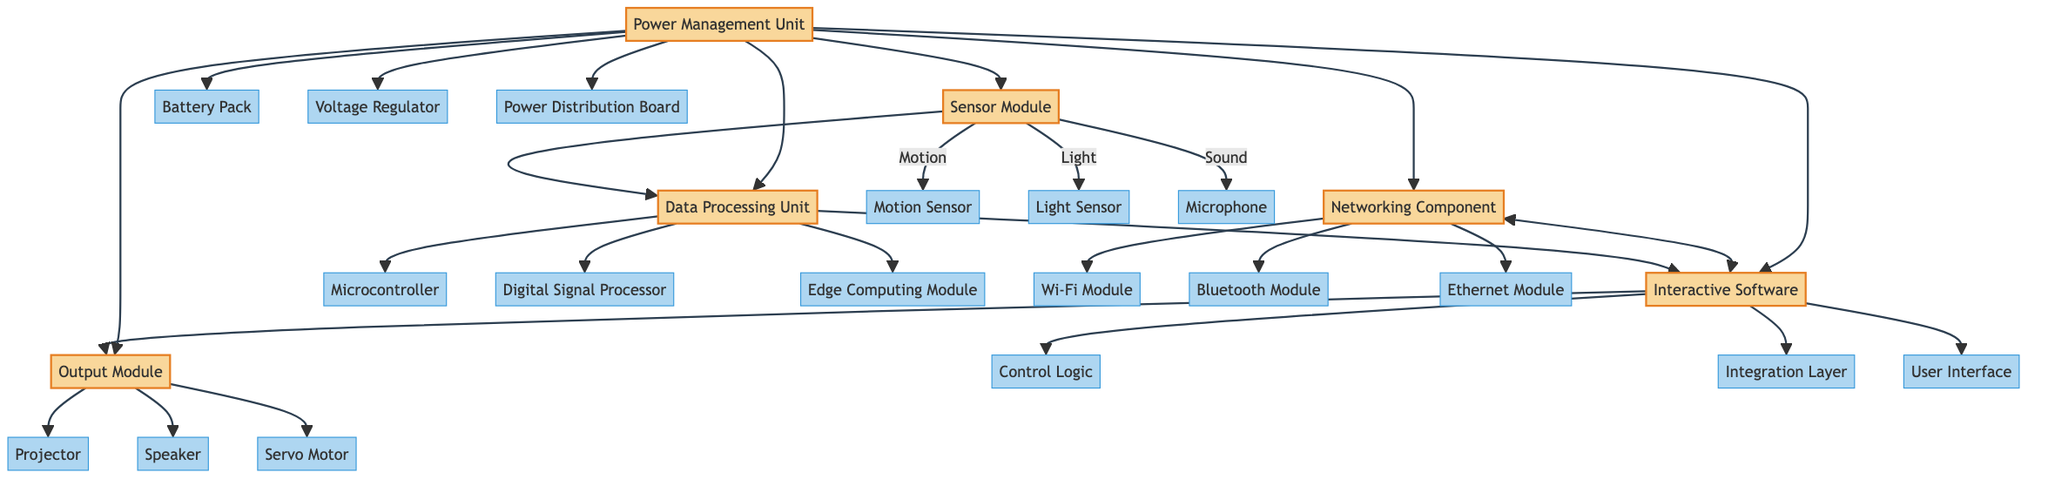What is the main purpose of the Sensor Module? The Sensor Module captures environmental inputs such as motion, light, and sound. This is indicated by its description provided in the diagram.
Answer: Captures environmental inputs How many software modules are present in the Interactive Software? The Interactive Software consists of three software modules: Control Logic, Integration Layer, and User Interface. Counting these components shows that there are three modules.
Answer: Three software modules Which module communicates bidirectionally with the Networking Component? The Interactive Software communicates bidirectionally with the Networking Component, as shown by the two-way arrow between these two modules in the diagram.
Answer: Interactive Software What types of inputs does the Sensor Module provide? The inputs from the Sensor Module include Motion, Light, and Sound, which are labeled on the connections from the Sensor Module to its components in the diagram.
Answer: Motion, Light, Sound How is power distributed to all components? The Power Management Unit distributes power to other components (Sensor Module, Data Processing Unit, Interactive Software, Output Module, Networking Component) as indicated by its connections in the diagram.
Answer: Power Management Unit Which output device is associated with audio feedback? The Speaker component in the Output Module is associated with audio feedback, as it is listed under the Outputs in the diagram.
Answer: Speaker In total, how many main modules are there in the entire block diagram? The entire block diagram consists of six main modules: Sensor Module, Data Processing Unit, Interactive Software, Output Module, Networking Component, and Power Management Unit. Counting these gives a total of six modules.
Answer: Six main modules What type of processing component is included in the Data Processing Unit? The Data Processing Unit includes a Microcontroller, Digital Signal Processor, and Edge Computing Module, all of which are processing components as categorized in the diagram.
Answer: Processing components What is the function of the Power Management Unit? The Power Management Unit's function is to provide and regulate power to all components in the system, as stated in the description within the diagram.
Answer: Provides and regulates power 